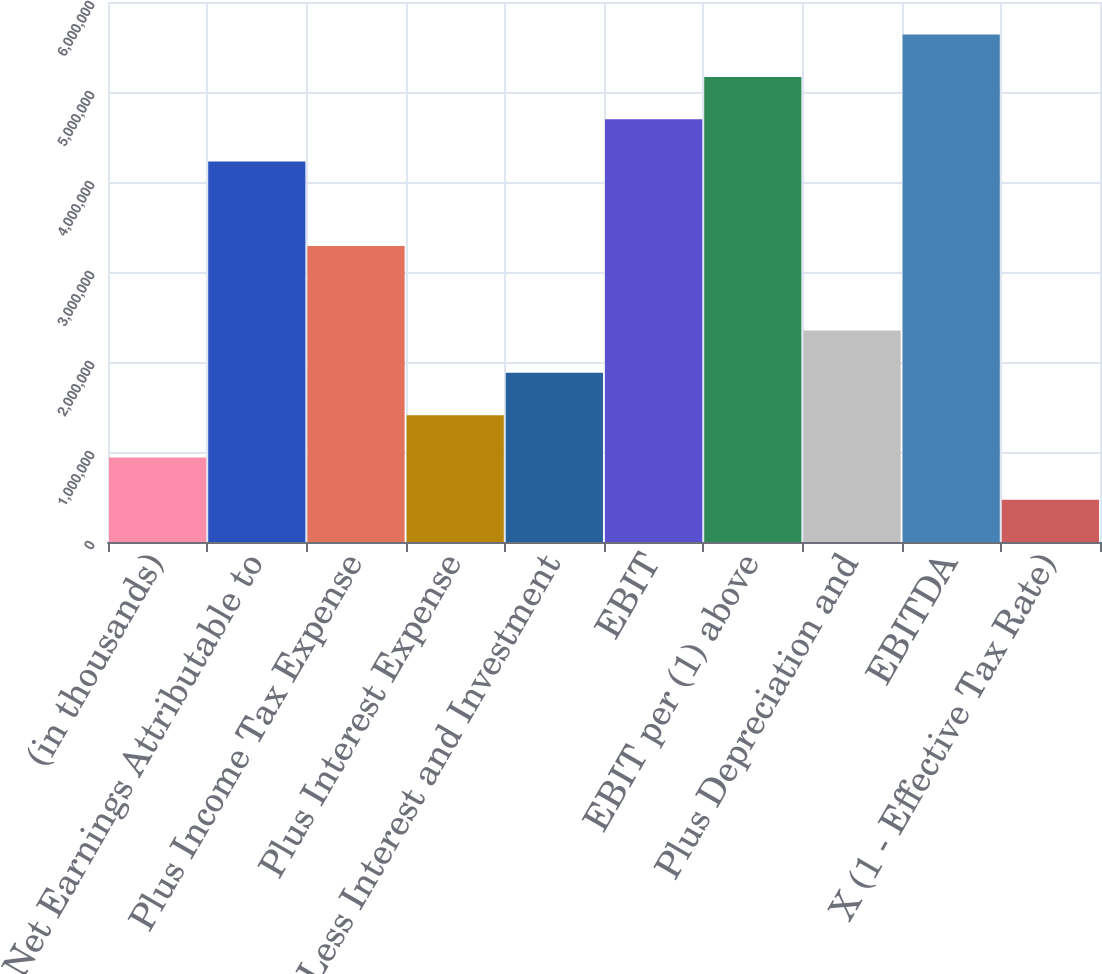Convert chart to OTSL. <chart><loc_0><loc_0><loc_500><loc_500><bar_chart><fcel>(in thousands)<fcel>Net Earnings Attributable to<fcel>Plus Income Tax Expense<fcel>Plus Interest Expense<fcel>Less Interest and Investment<fcel>EBIT<fcel>EBIT per (1) above<fcel>Plus Depreciation and<fcel>EBITDA<fcel>X (1 - Effective Tax Rate)<nl><fcel>939616<fcel>4.22821e+06<fcel>3.28861e+06<fcel>1.40942e+06<fcel>1.87921e+06<fcel>4.69801e+06<fcel>5.1678e+06<fcel>2.34901e+06<fcel>5.6376e+06<fcel>469818<nl></chart> 